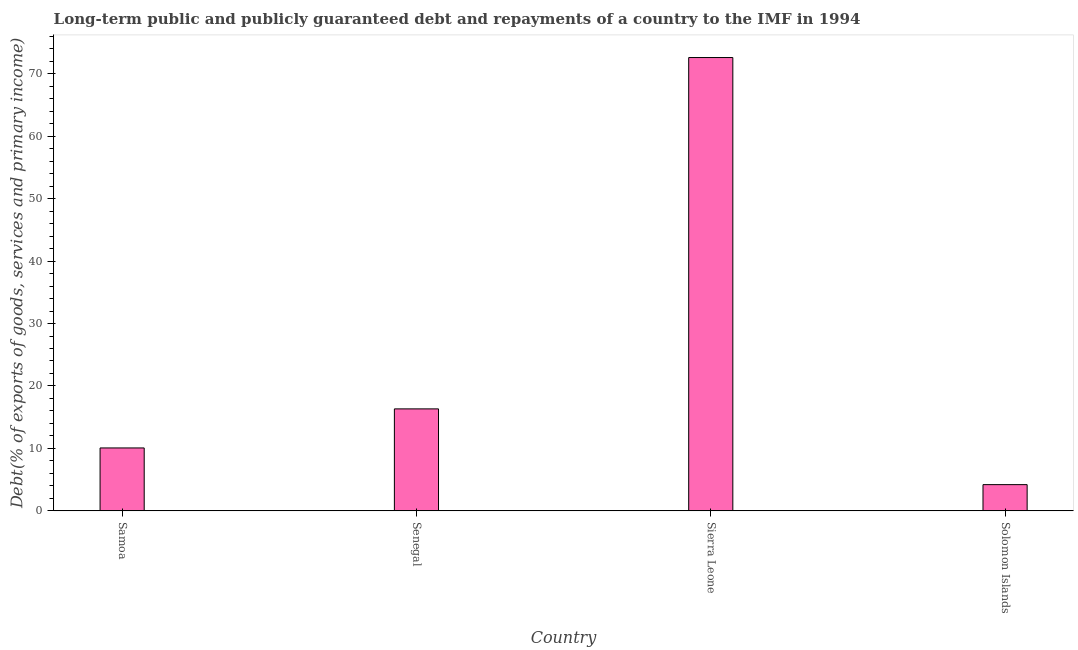Does the graph contain grids?
Keep it short and to the point. No. What is the title of the graph?
Give a very brief answer. Long-term public and publicly guaranteed debt and repayments of a country to the IMF in 1994. What is the label or title of the X-axis?
Your answer should be very brief. Country. What is the label or title of the Y-axis?
Make the answer very short. Debt(% of exports of goods, services and primary income). What is the debt service in Solomon Islands?
Your answer should be very brief. 4.2. Across all countries, what is the maximum debt service?
Your answer should be very brief. 72.61. Across all countries, what is the minimum debt service?
Your answer should be very brief. 4.2. In which country was the debt service maximum?
Your answer should be very brief. Sierra Leone. In which country was the debt service minimum?
Provide a succinct answer. Solomon Islands. What is the sum of the debt service?
Provide a succinct answer. 103.2. What is the difference between the debt service in Samoa and Senegal?
Provide a short and direct response. -6.25. What is the average debt service per country?
Provide a succinct answer. 25.8. What is the median debt service?
Your answer should be very brief. 13.2. In how many countries, is the debt service greater than 34 %?
Offer a very short reply. 1. What is the ratio of the debt service in Senegal to that in Solomon Islands?
Your answer should be compact. 3.89. What is the difference between the highest and the second highest debt service?
Offer a terse response. 56.28. What is the difference between the highest and the lowest debt service?
Your answer should be compact. 68.41. In how many countries, is the debt service greater than the average debt service taken over all countries?
Your response must be concise. 1. How many bars are there?
Your answer should be compact. 4. Are all the bars in the graph horizontal?
Offer a terse response. No. What is the Debt(% of exports of goods, services and primary income) in Samoa?
Provide a succinct answer. 10.07. What is the Debt(% of exports of goods, services and primary income) in Senegal?
Offer a very short reply. 16.33. What is the Debt(% of exports of goods, services and primary income) of Sierra Leone?
Your response must be concise. 72.61. What is the Debt(% of exports of goods, services and primary income) of Solomon Islands?
Make the answer very short. 4.2. What is the difference between the Debt(% of exports of goods, services and primary income) in Samoa and Senegal?
Provide a short and direct response. -6.25. What is the difference between the Debt(% of exports of goods, services and primary income) in Samoa and Sierra Leone?
Offer a very short reply. -62.53. What is the difference between the Debt(% of exports of goods, services and primary income) in Samoa and Solomon Islands?
Offer a very short reply. 5.88. What is the difference between the Debt(% of exports of goods, services and primary income) in Senegal and Sierra Leone?
Offer a very short reply. -56.28. What is the difference between the Debt(% of exports of goods, services and primary income) in Senegal and Solomon Islands?
Keep it short and to the point. 12.13. What is the difference between the Debt(% of exports of goods, services and primary income) in Sierra Leone and Solomon Islands?
Ensure brevity in your answer.  68.41. What is the ratio of the Debt(% of exports of goods, services and primary income) in Samoa to that in Senegal?
Your answer should be very brief. 0.62. What is the ratio of the Debt(% of exports of goods, services and primary income) in Samoa to that in Sierra Leone?
Offer a terse response. 0.14. What is the ratio of the Debt(% of exports of goods, services and primary income) in Senegal to that in Sierra Leone?
Give a very brief answer. 0.23. What is the ratio of the Debt(% of exports of goods, services and primary income) in Senegal to that in Solomon Islands?
Give a very brief answer. 3.89. What is the ratio of the Debt(% of exports of goods, services and primary income) in Sierra Leone to that in Solomon Islands?
Provide a succinct answer. 17.3. 